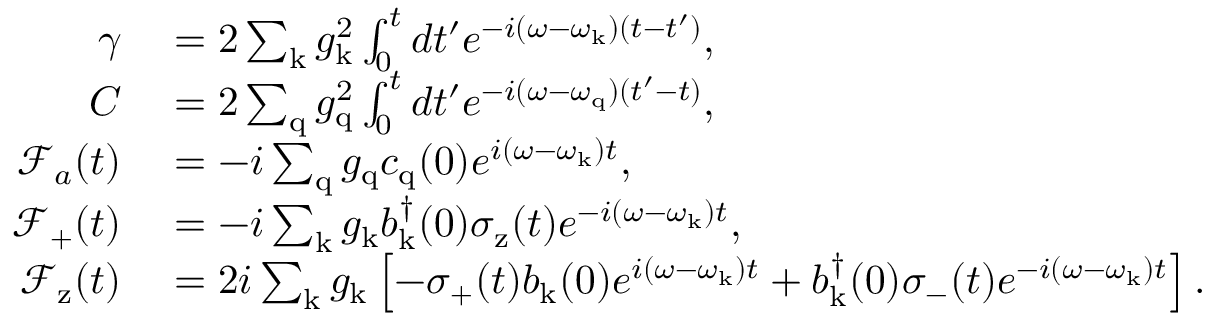<formula> <loc_0><loc_0><loc_500><loc_500>\begin{array} { r l } { \gamma } & = 2 \sum _ { k } g _ { k } ^ { 2 } \int _ { 0 } ^ { t } d t ^ { \prime } e ^ { - i ( \omega - \omega _ { k } ) ( t - t ^ { \prime } ) } , } \\ { C } & = 2 \sum _ { q } g _ { q } ^ { 2 } \int _ { 0 } ^ { t } d t ^ { \prime } e ^ { - i ( \omega - \omega _ { q } ) ( t ^ { \prime } - t ) } , } \\ { \mathcal { F } _ { a } ( t ) } & = - i \sum _ { q } g _ { q } c _ { q } ( 0 ) e ^ { i ( \omega - \omega _ { k } ) t } , } \\ { \mathcal { F } _ { + } ( t ) } & = - i \sum _ { k } g _ { k } b _ { k } ^ { \dagger } ( 0 ) \sigma _ { z } ( t ) e ^ { - i ( \omega - \omega _ { k } ) t } , } \\ { \mathcal { F } _ { z } ( t ) } & = 2 i \sum _ { k } g _ { k } \left [ - \sigma _ { + } ( t ) b _ { k } ( 0 ) e ^ { i ( \omega - \omega _ { k } ) t } + b _ { k } ^ { \dagger } ( 0 ) \sigma _ { - } ( t ) e ^ { - i ( \omega - \omega _ { k } ) t } \right ] . } \end{array}</formula> 